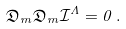Convert formula to latex. <formula><loc_0><loc_0><loc_500><loc_500>\mathfrak { D } _ { m } \mathfrak { D } _ { m } \mathcal { I } ^ { \Lambda } = 0 \, .</formula> 